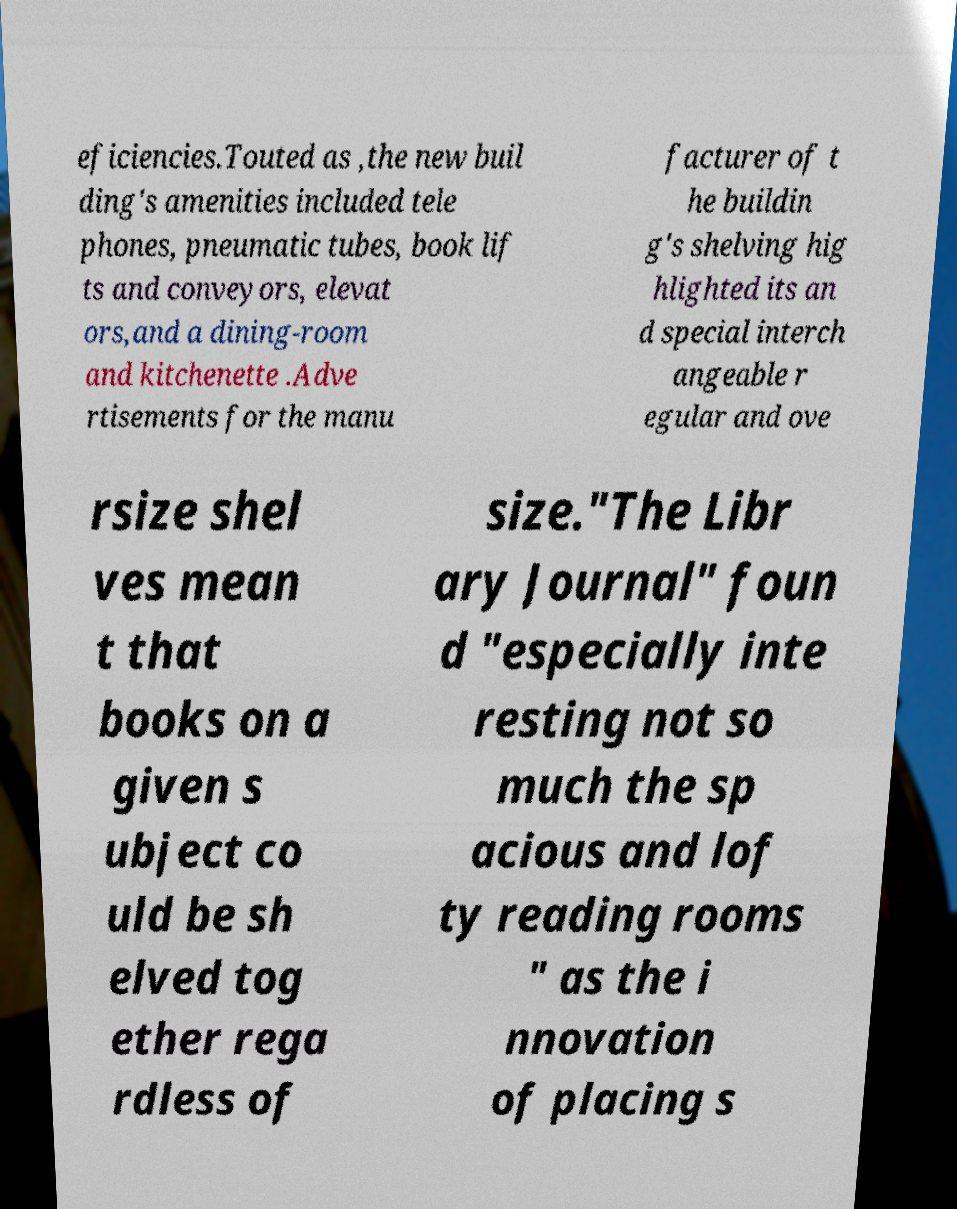For documentation purposes, I need the text within this image transcribed. Could you provide that? eficiencies.Touted as ,the new buil ding's amenities included tele phones, pneumatic tubes, book lif ts and conveyors, elevat ors,and a dining-room and kitchenette .Adve rtisements for the manu facturer of t he buildin g's shelving hig hlighted its an d special interch angeable r egular and ove rsize shel ves mean t that books on a given s ubject co uld be sh elved tog ether rega rdless of size."The Libr ary Journal" foun d "especially inte resting not so much the sp acious and lof ty reading rooms " as the i nnovation of placing s 